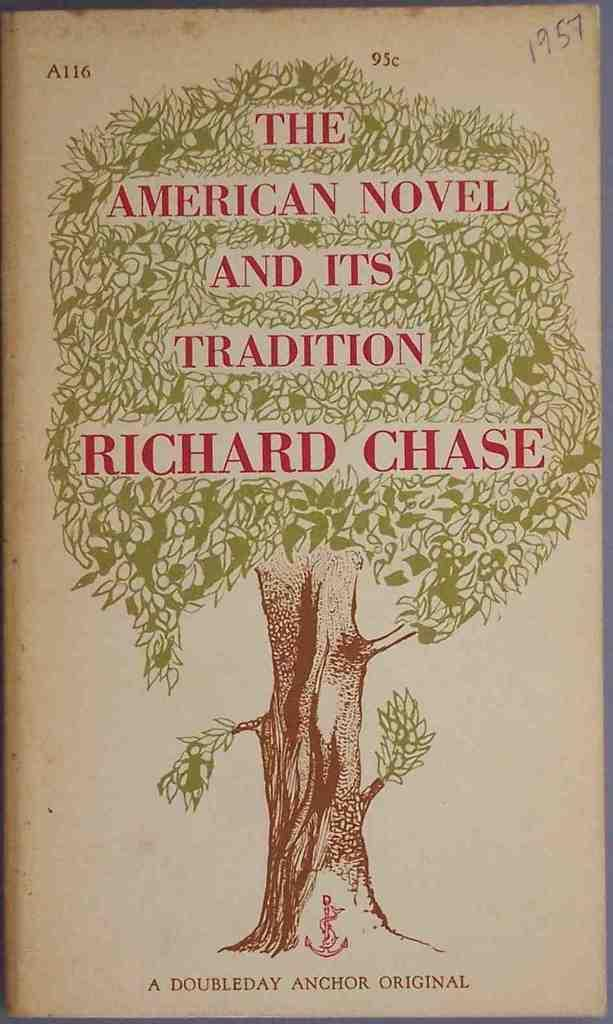<image>
Summarize the visual content of the image. a tree that says The American Novel on it 